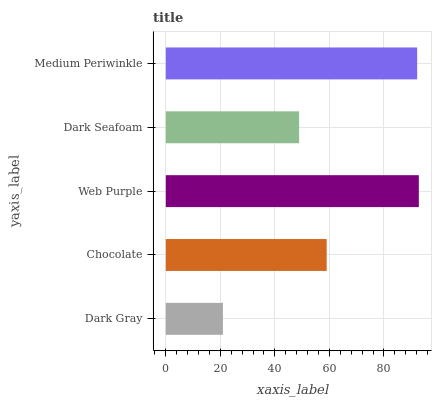Is Dark Gray the minimum?
Answer yes or no. Yes. Is Web Purple the maximum?
Answer yes or no. Yes. Is Chocolate the minimum?
Answer yes or no. No. Is Chocolate the maximum?
Answer yes or no. No. Is Chocolate greater than Dark Gray?
Answer yes or no. Yes. Is Dark Gray less than Chocolate?
Answer yes or no. Yes. Is Dark Gray greater than Chocolate?
Answer yes or no. No. Is Chocolate less than Dark Gray?
Answer yes or no. No. Is Chocolate the high median?
Answer yes or no. Yes. Is Chocolate the low median?
Answer yes or no. Yes. Is Dark Seafoam the high median?
Answer yes or no. No. Is Medium Periwinkle the low median?
Answer yes or no. No. 